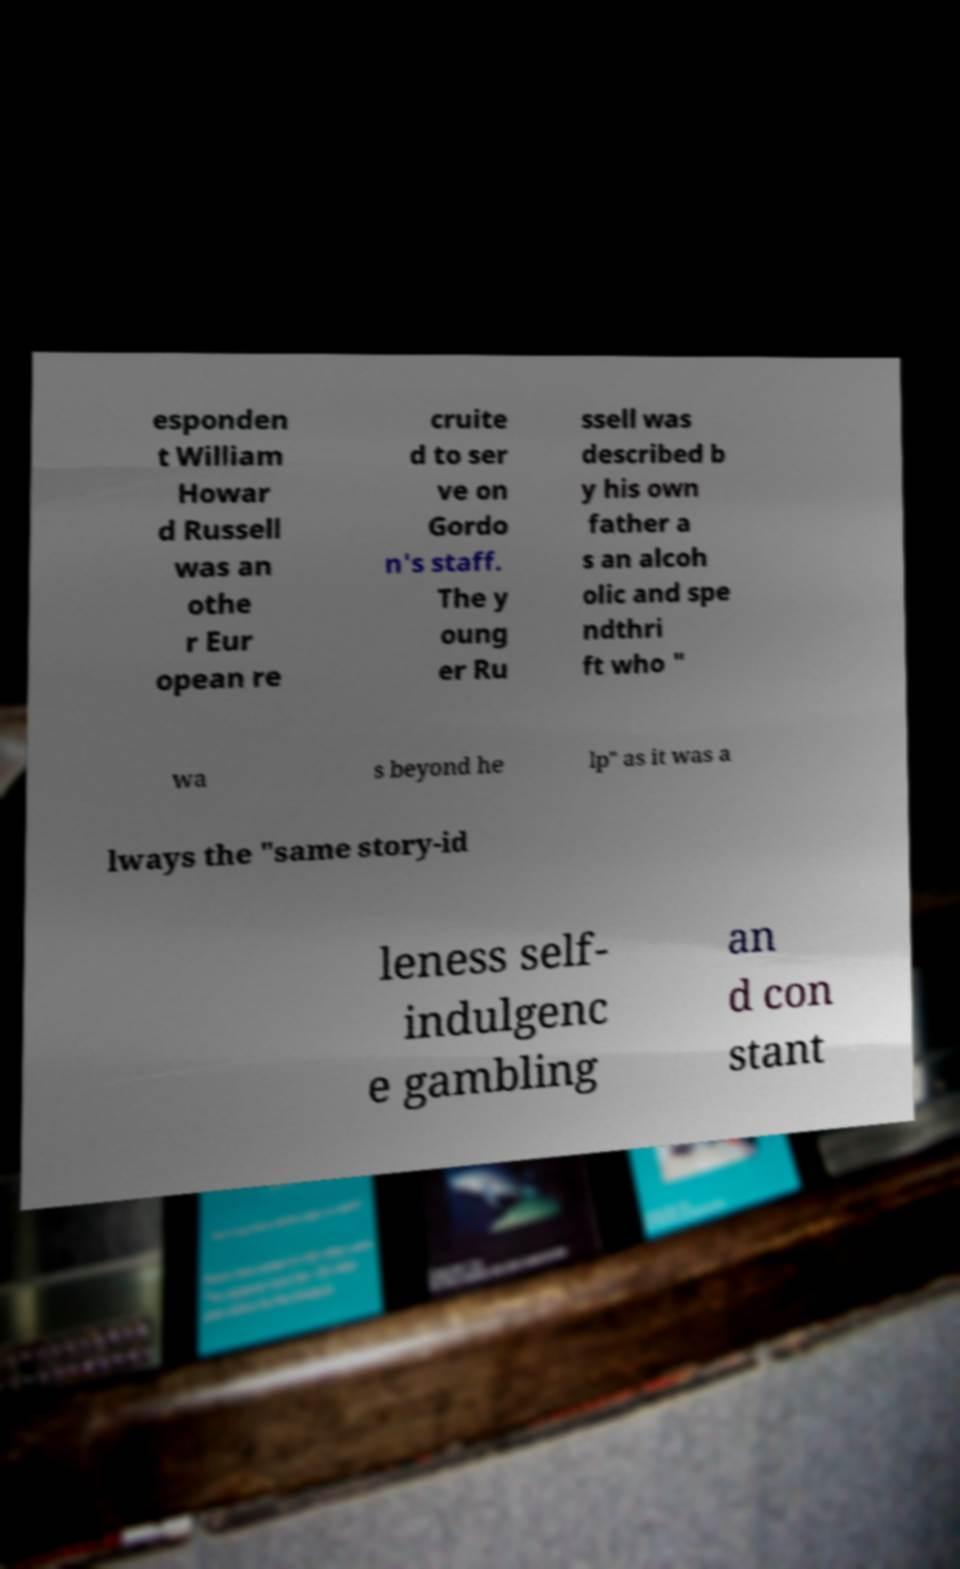Could you extract and type out the text from this image? esponden t William Howar d Russell was an othe r Eur opean re cruite d to ser ve on Gordo n's staff. The y oung er Ru ssell was described b y his own father a s an alcoh olic and spe ndthri ft who " wa s beyond he lp" as it was a lways the "same story-id leness self- indulgenc e gambling an d con stant 